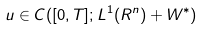Convert formula to latex. <formula><loc_0><loc_0><loc_500><loc_500>u \in C ( [ 0 , T ] ; L ^ { 1 } ( R ^ { n } ) + W ^ { \ast } )</formula> 